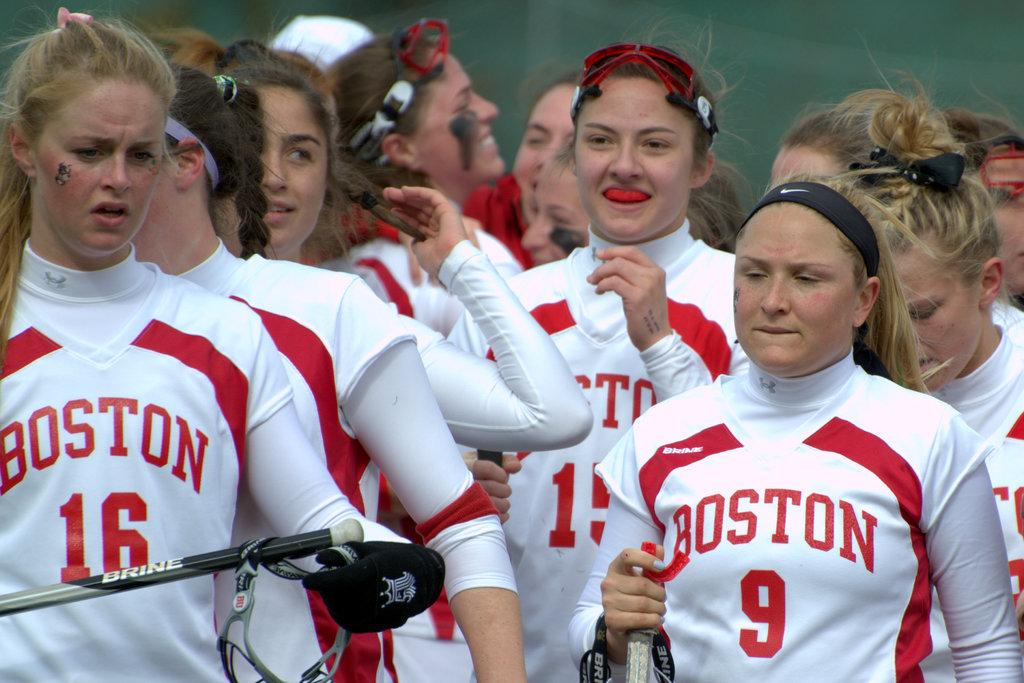<image>
Describe the image concisely. A bunch of female athletes wearing Boston uniforms are gathered together. 